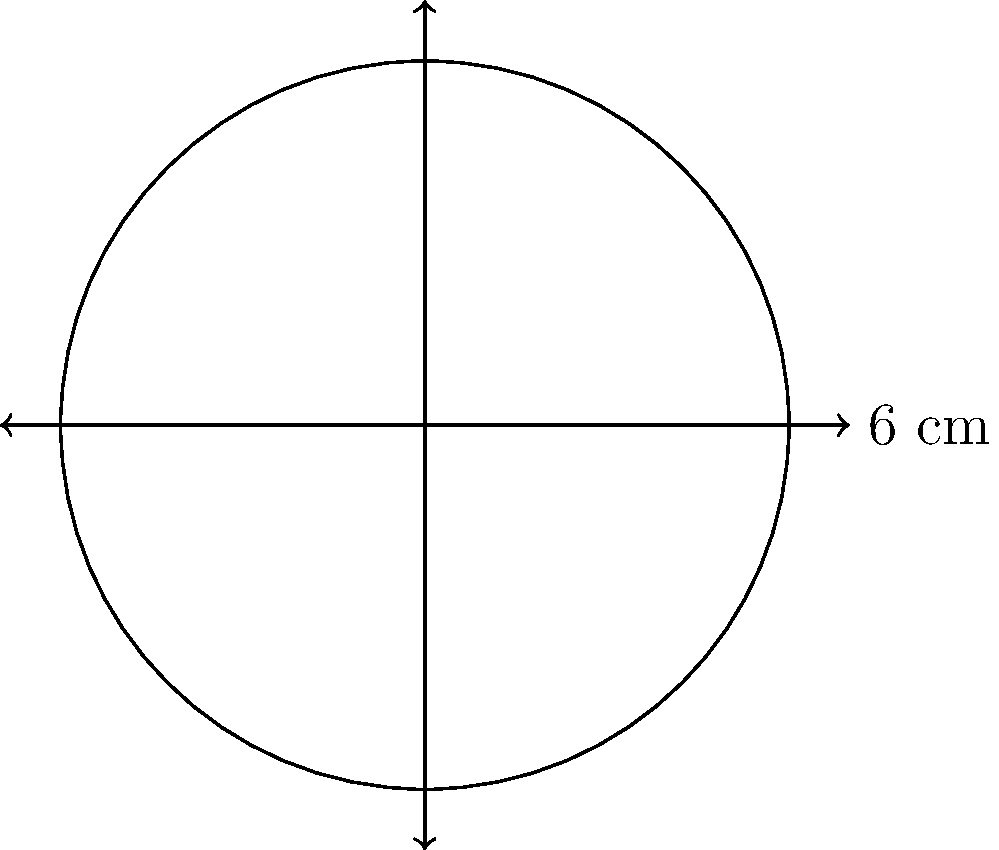You're looking for a compact contact lens case to fit in your travel kit. The optometrist shows you a circular case with a diameter of 6 cm. What is the area of the base of this contact lens case? To find the area of the circular base of the contact lens case, we need to follow these steps:

1. Identify the given information:
   - The diameter of the circular base is 6 cm

2. Calculate the radius:
   - Radius = Diameter ÷ 2
   - Radius = 6 cm ÷ 2 = 3 cm

3. Use the formula for the area of a circle:
   - Area = π × r²
   - Where r is the radius

4. Substitute the values into the formula:
   - Area = π × (3 cm)²
   - Area = π × 9 cm²

5. Calculate the result:
   - Area ≈ 28.27 cm²

Therefore, the area of the base of the contact lens case is approximately 28.27 square centimeters.
Answer: $28.27 \text{ cm}^2$ 